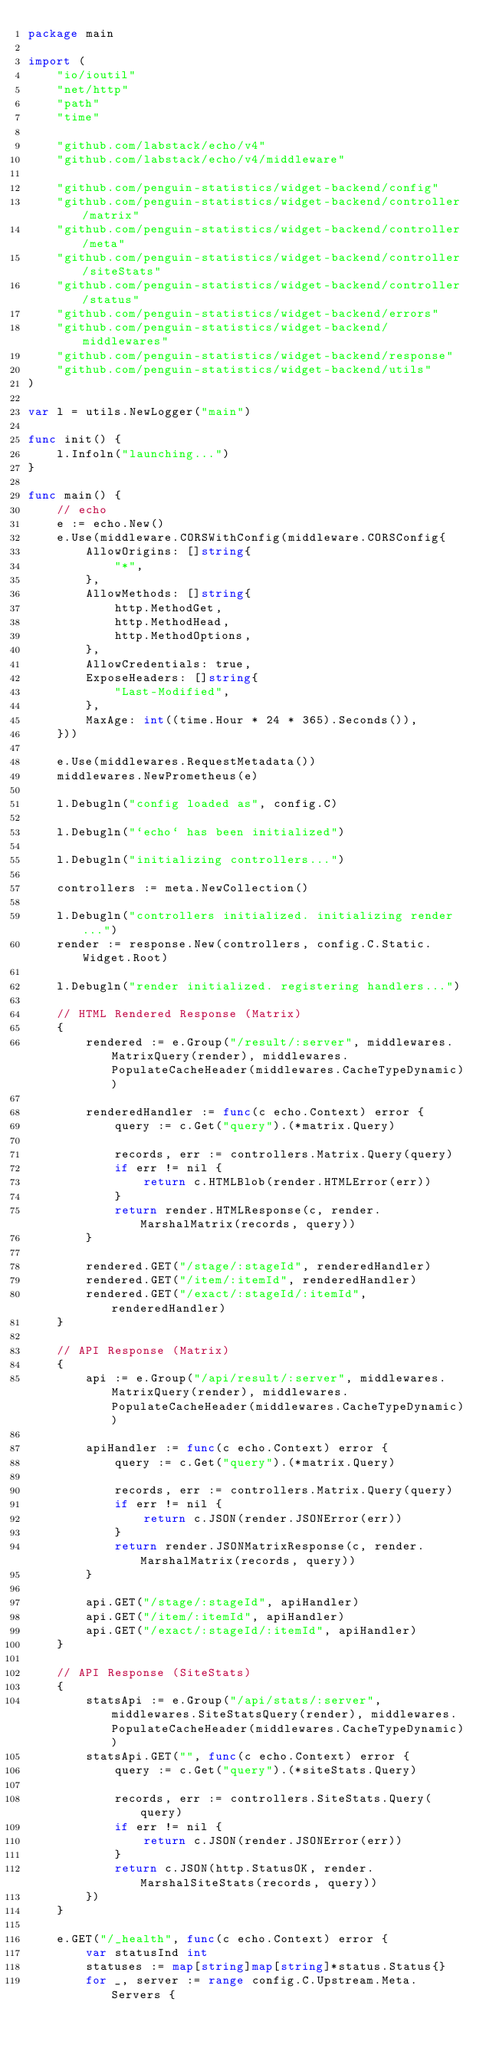Convert code to text. <code><loc_0><loc_0><loc_500><loc_500><_Go_>package main

import (
	"io/ioutil"
	"net/http"
	"path"
	"time"

	"github.com/labstack/echo/v4"
	"github.com/labstack/echo/v4/middleware"

	"github.com/penguin-statistics/widget-backend/config"
	"github.com/penguin-statistics/widget-backend/controller/matrix"
	"github.com/penguin-statistics/widget-backend/controller/meta"
	"github.com/penguin-statistics/widget-backend/controller/siteStats"
	"github.com/penguin-statistics/widget-backend/controller/status"
	"github.com/penguin-statistics/widget-backend/errors"
	"github.com/penguin-statistics/widget-backend/middlewares"
	"github.com/penguin-statistics/widget-backend/response"
	"github.com/penguin-statistics/widget-backend/utils"
)

var l = utils.NewLogger("main")

func init() {
	l.Infoln("launching...")
}

func main() {
	// echo
	e := echo.New()
	e.Use(middleware.CORSWithConfig(middleware.CORSConfig{
		AllowOrigins: []string{
			"*",
		},
		AllowMethods: []string{
			http.MethodGet,
			http.MethodHead,
			http.MethodOptions,
		},
		AllowCredentials: true,
		ExposeHeaders: []string{
			"Last-Modified",
		},
		MaxAge: int((time.Hour * 24 * 365).Seconds()),
	}))

	e.Use(middlewares.RequestMetadata())
	middlewares.NewPrometheus(e)

	l.Debugln("config loaded as", config.C)

	l.Debugln("`echo` has been initialized")

	l.Debugln("initializing controllers...")

	controllers := meta.NewCollection()

	l.Debugln("controllers initialized. initializing render...")
	render := response.New(controllers, config.C.Static.Widget.Root)

	l.Debugln("render initialized. registering handlers...")

	// HTML Rendered Response (Matrix)
	{
		rendered := e.Group("/result/:server", middlewares.MatrixQuery(render), middlewares.PopulateCacheHeader(middlewares.CacheTypeDynamic))

		renderedHandler := func(c echo.Context) error {
			query := c.Get("query").(*matrix.Query)

			records, err := controllers.Matrix.Query(query)
			if err != nil {
				return c.HTMLBlob(render.HTMLError(err))
			}
			return render.HTMLResponse(c, render.MarshalMatrix(records, query))
		}

		rendered.GET("/stage/:stageId", renderedHandler)
		rendered.GET("/item/:itemId", renderedHandler)
		rendered.GET("/exact/:stageId/:itemId", renderedHandler)
	}

	// API Response (Matrix)
	{
		api := e.Group("/api/result/:server", middlewares.MatrixQuery(render), middlewares.PopulateCacheHeader(middlewares.CacheTypeDynamic))

		apiHandler := func(c echo.Context) error {
			query := c.Get("query").(*matrix.Query)

			records, err := controllers.Matrix.Query(query)
			if err != nil {
				return c.JSON(render.JSONError(err))
			}
			return render.JSONMatrixResponse(c, render.MarshalMatrix(records, query))
		}

		api.GET("/stage/:stageId", apiHandler)
		api.GET("/item/:itemId", apiHandler)
		api.GET("/exact/:stageId/:itemId", apiHandler)
	}

	// API Response (SiteStats)
	{
		statsApi := e.Group("/api/stats/:server", middlewares.SiteStatsQuery(render), middlewares.PopulateCacheHeader(middlewares.CacheTypeDynamic))
		statsApi.GET("", func(c echo.Context) error {
			query := c.Get("query").(*siteStats.Query)

			records, err := controllers.SiteStats.Query(query)
			if err != nil {
				return c.JSON(render.JSONError(err))
			}
			return c.JSON(http.StatusOK, render.MarshalSiteStats(records, query))
		})
	}

	e.GET("/_health", func(c echo.Context) error {
		var statusInd int
		statuses := map[string]map[string]*status.Status{}
		for _, server := range config.C.Upstream.Meta.Servers {</code> 